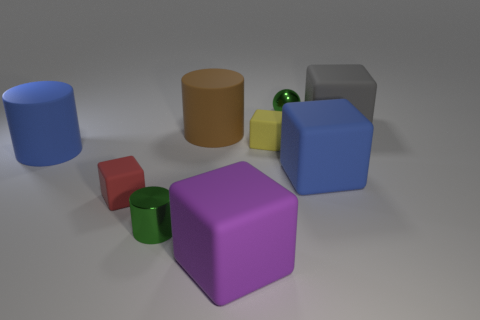Subtract all blue cubes. How many cubes are left? 4 Subtract all purple blocks. How many blocks are left? 4 Subtract all green cubes. Subtract all brown cylinders. How many cubes are left? 5 Add 1 tiny green spheres. How many objects exist? 10 Subtract all cylinders. How many objects are left? 6 Add 9 yellow things. How many yellow things exist? 10 Subtract 0 gray balls. How many objects are left? 9 Subtract all small purple objects. Subtract all small metallic things. How many objects are left? 7 Add 9 red objects. How many red objects are left? 10 